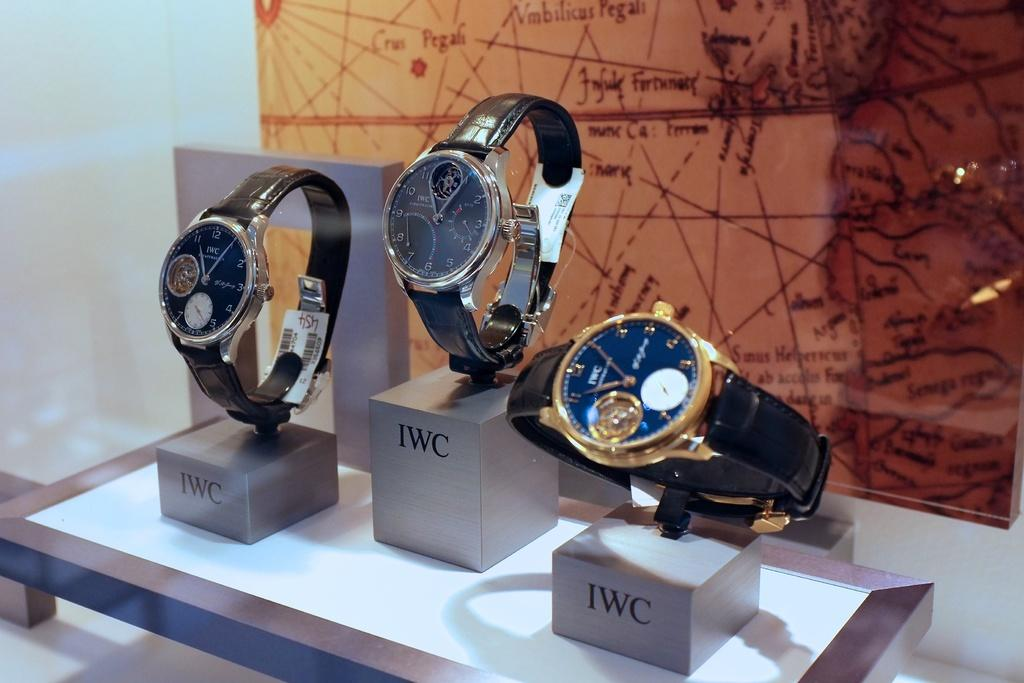Provide a one-sentence caption for the provided image. Three watches that are labeled IWC in front of a map. 